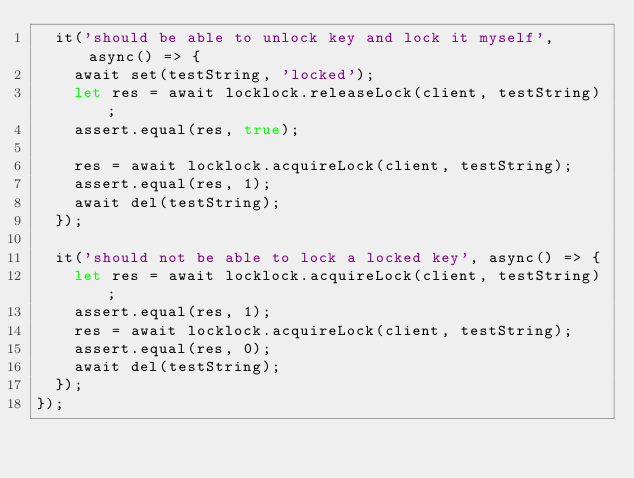Convert code to text. <code><loc_0><loc_0><loc_500><loc_500><_JavaScript_>  it('should be able to unlock key and lock it myself', async() => {
    await set(testString, 'locked');
    let res = await locklock.releaseLock(client, testString);
    assert.equal(res, true);

    res = await locklock.acquireLock(client, testString);
    assert.equal(res, 1);
    await del(testString);
  });

  it('should not be able to lock a locked key', async() => {
    let res = await locklock.acquireLock(client, testString);
    assert.equal(res, 1);
    res = await locklock.acquireLock(client, testString);
    assert.equal(res, 0);
    await del(testString);
  });
});
</code> 